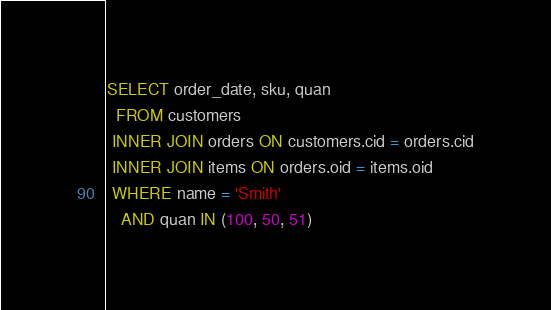Convert code to text. <code><loc_0><loc_0><loc_500><loc_500><_SQL_>SELECT order_date, sku, quan
  FROM customers
 INNER JOIN orders ON customers.cid = orders.cid
 INNER JOIN items ON orders.oid = items.oid
 WHERE name = 'Smith'
   AND quan IN (100, 50, 51)
</code> 